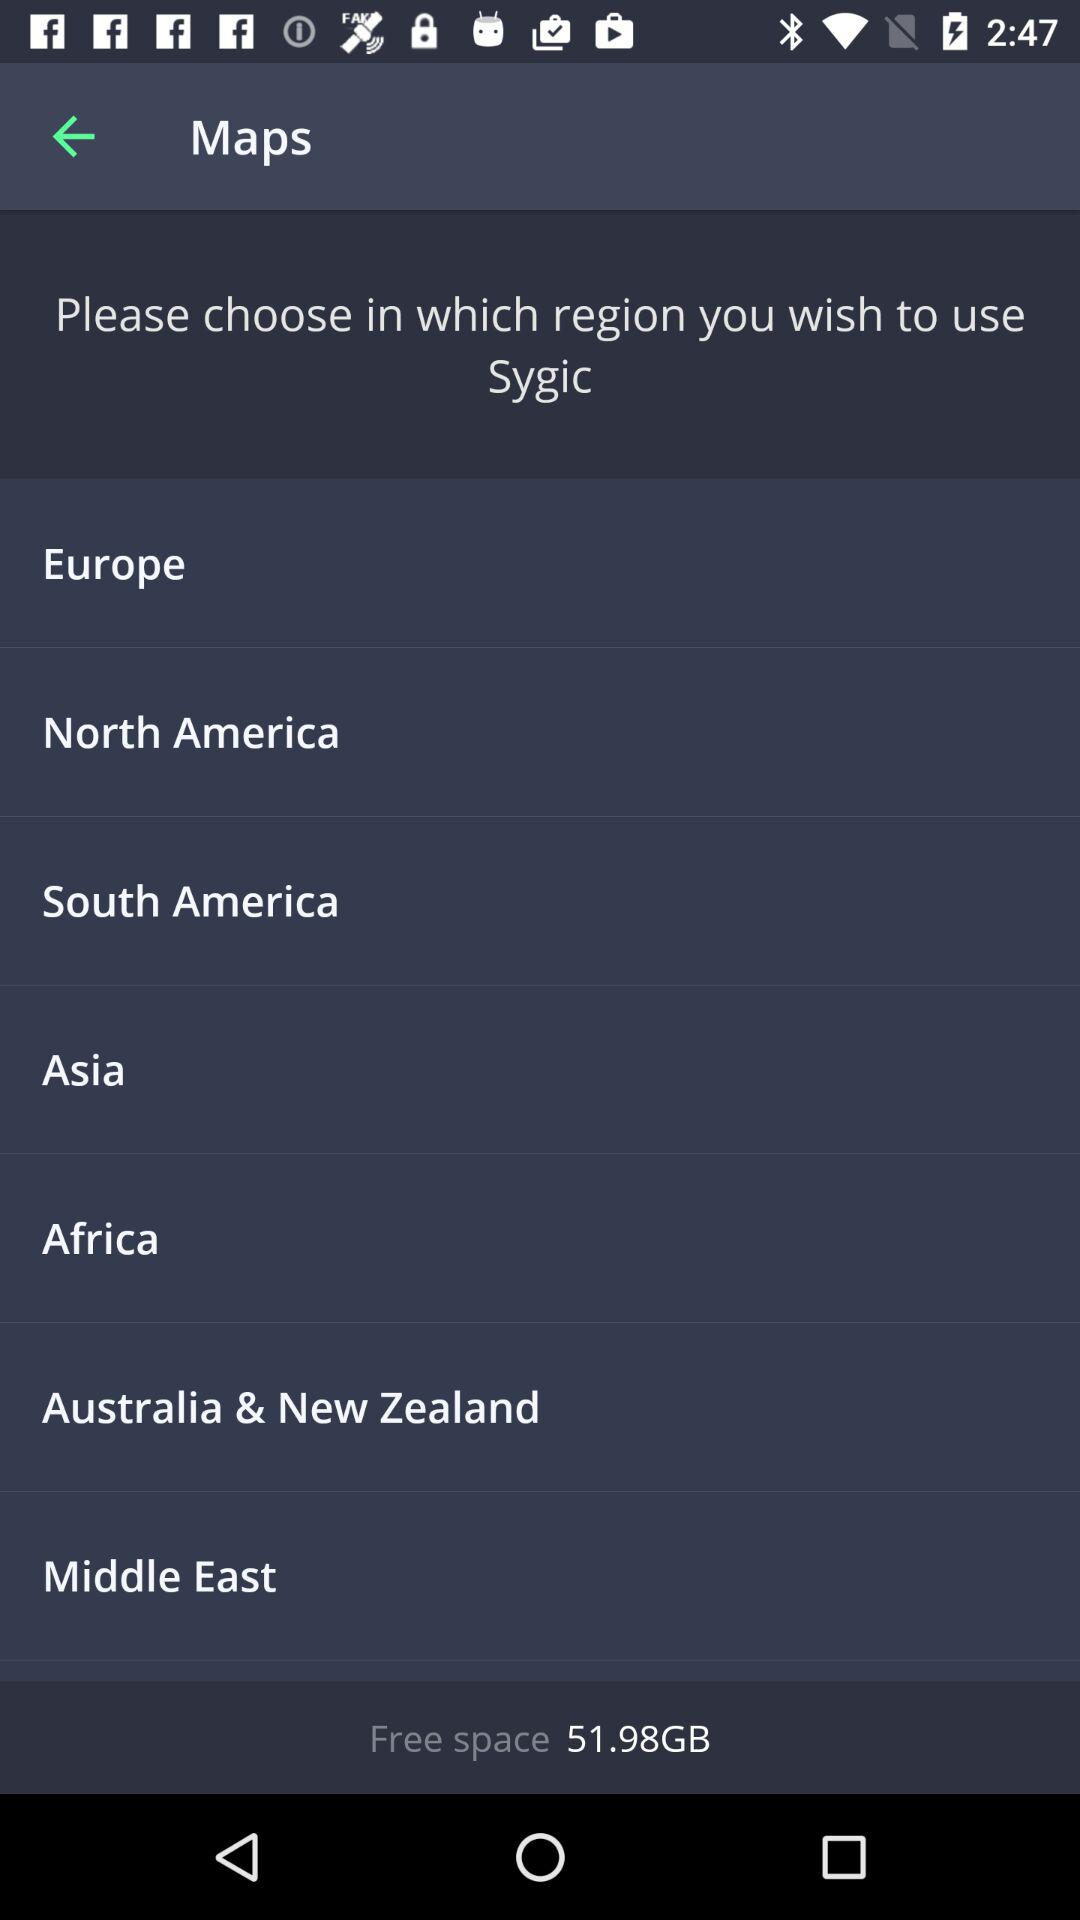Is this a map for a specific navigation app? Yes, the maps on display are for the Sygic navigation application, which is a GPS navigation software available for various devices. What features might the Sygic app have? Sygic navigation app typically features offline maps, turn-by-turn voice-guided navigation, speed limit warnings, traffic information, and points of interest search. It's tailored for both pedestrian and automotive use. 